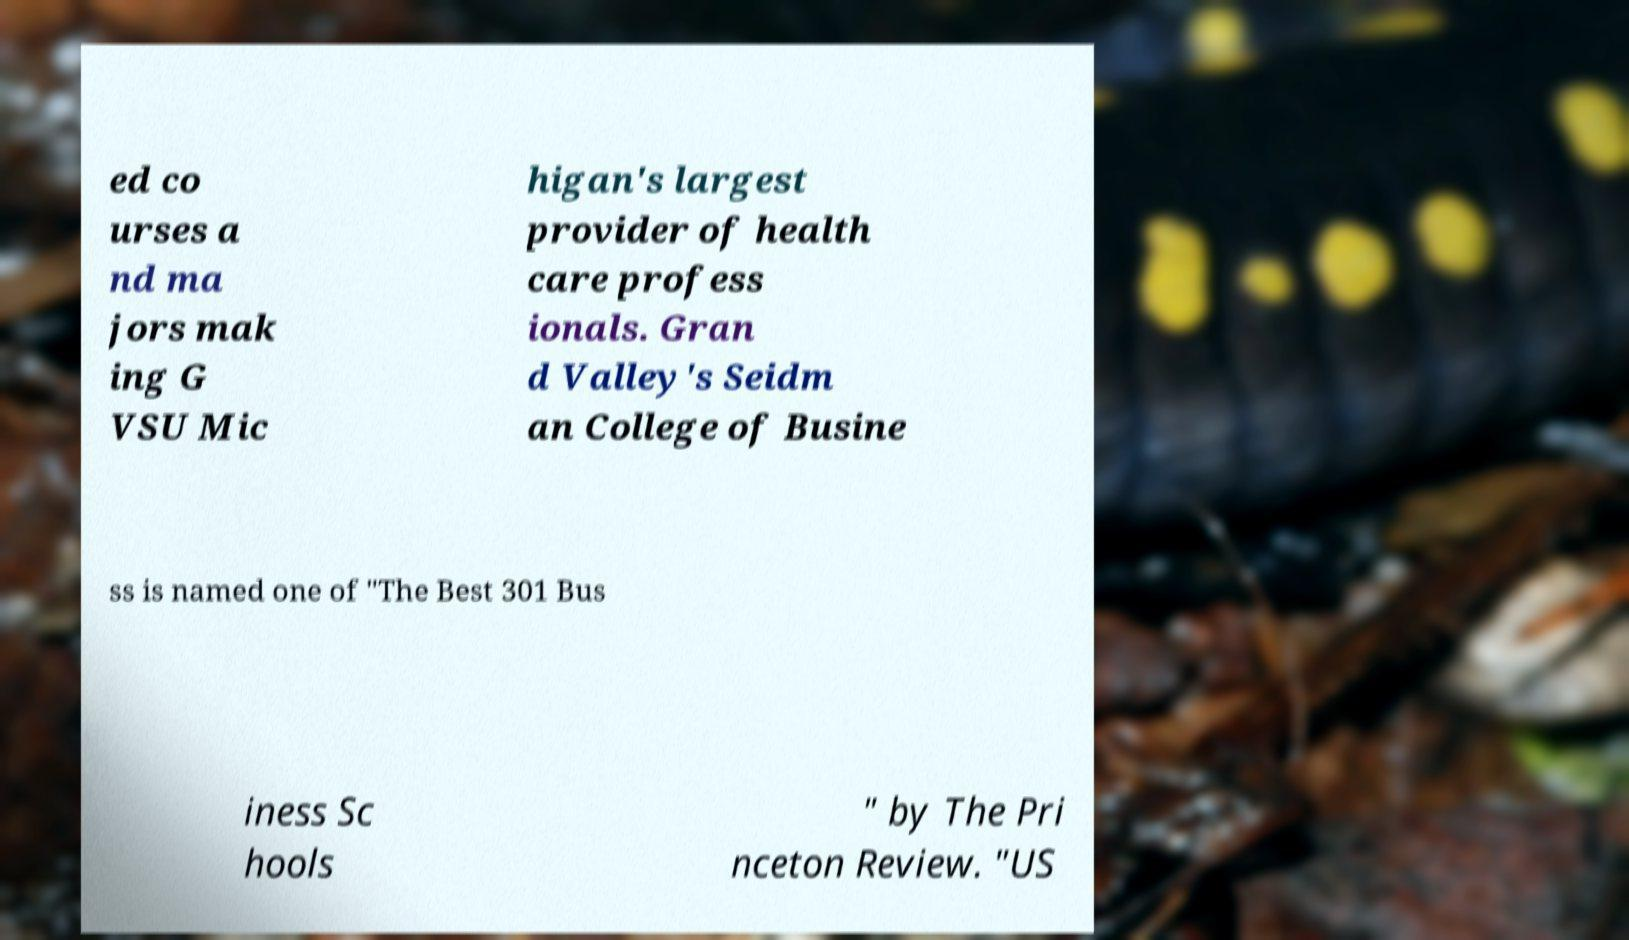Please read and relay the text visible in this image. What does it say? ed co urses a nd ma jors mak ing G VSU Mic higan's largest provider of health care profess ionals. Gran d Valley's Seidm an College of Busine ss is named one of "The Best 301 Bus iness Sc hools " by The Pri nceton Review. "US 